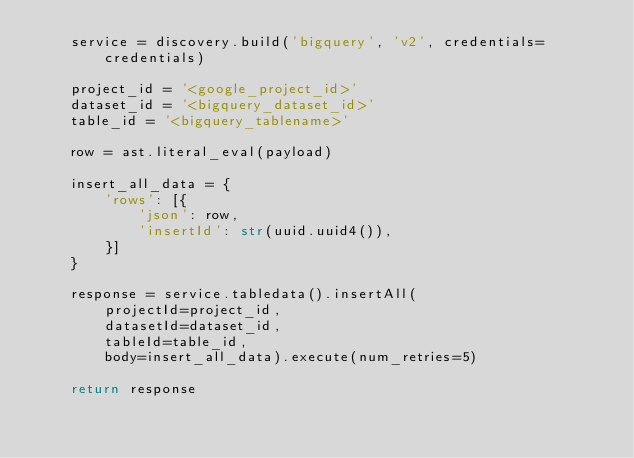Convert code to text. <code><loc_0><loc_0><loc_500><loc_500><_Python_>    service = discovery.build('bigquery', 'v2', credentials=credentials)

    project_id = '<google_project_id>'
    dataset_id = '<bigquery_dataset_id>'
    table_id = '<bigquery_tablename>'

    row = ast.literal_eval(payload)

    insert_all_data = {
        'rows': [{
            'json': row,
            'insertId': str(uuid.uuid4()),
        }]
    }

    response = service.tabledata().insertAll(
        projectId=project_id,
        datasetId=dataset_id,
        tableId=table_id,
        body=insert_all_data).execute(num_retries=5)

    return response
</code> 